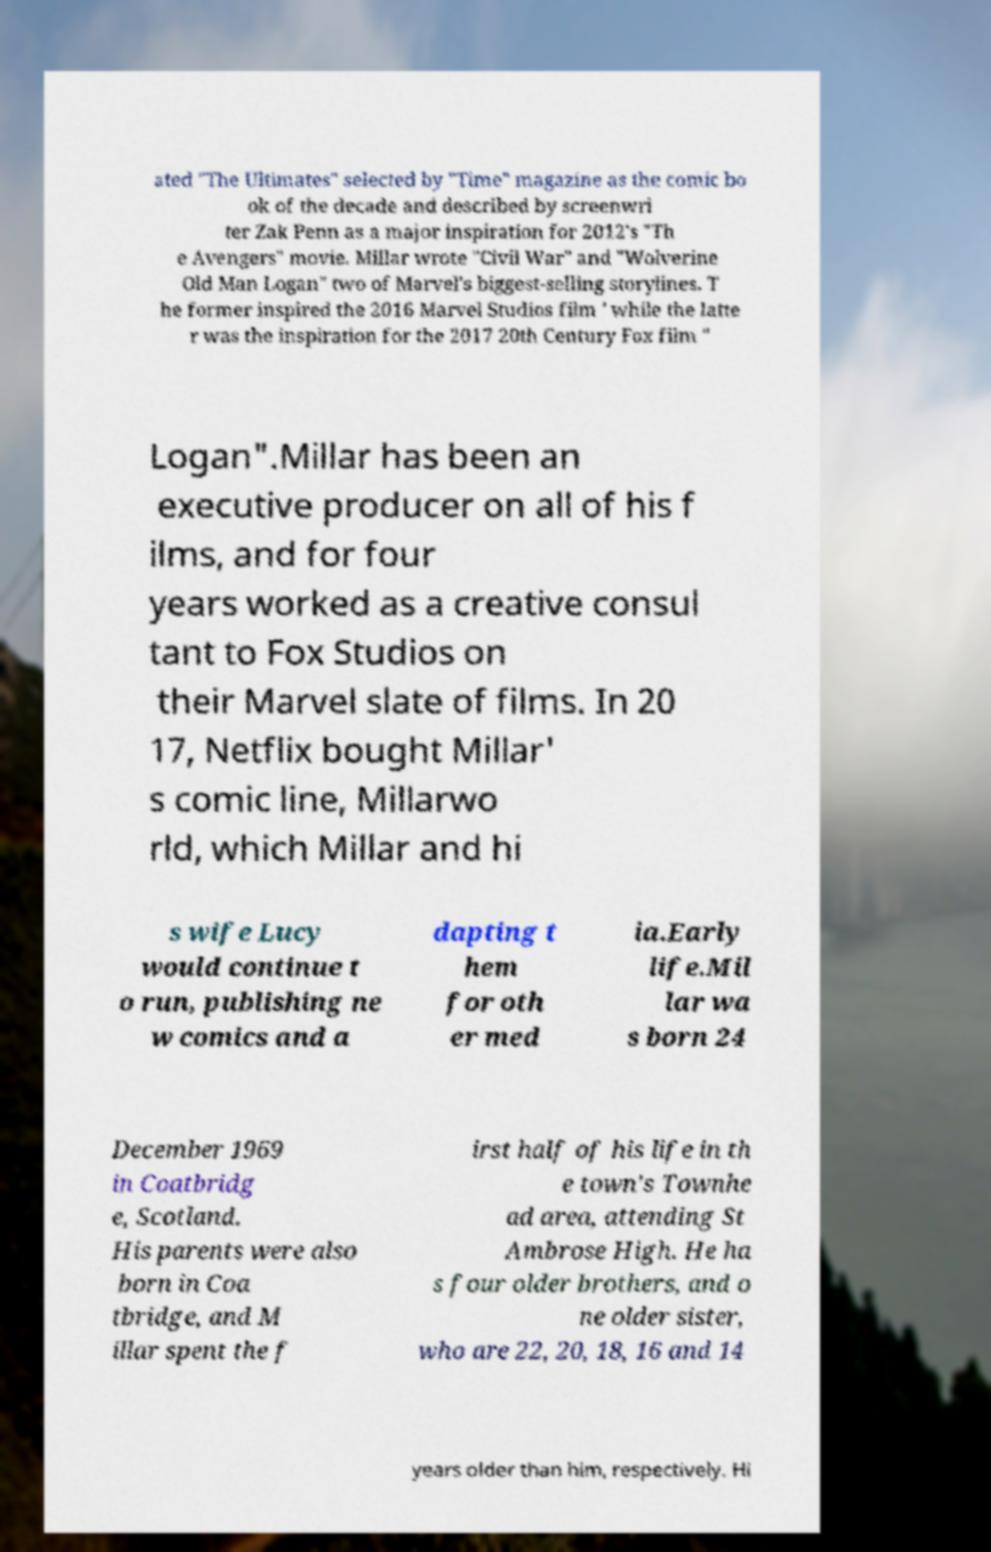Could you extract and type out the text from this image? ated "The Ultimates" selected by "Time" magazine as the comic bo ok of the decade and described by screenwri ter Zak Penn as a major inspiration for 2012's "Th e Avengers" movie. Millar wrote "Civil War" and "Wolverine Old Man Logan" two of Marvel's biggest-selling storylines. T he former inspired the 2016 Marvel Studios film ' while the latte r was the inspiration for the 2017 20th Century Fox film " Logan".Millar has been an executive producer on all of his f ilms, and for four years worked as a creative consul tant to Fox Studios on their Marvel slate of films. In 20 17, Netflix bought Millar' s comic line, Millarwo rld, which Millar and hi s wife Lucy would continue t o run, publishing ne w comics and a dapting t hem for oth er med ia.Early life.Mil lar wa s born 24 December 1969 in Coatbridg e, Scotland. His parents were also born in Coa tbridge, and M illar spent the f irst half of his life in th e town's Townhe ad area, attending St Ambrose High. He ha s four older brothers, and o ne older sister, who are 22, 20, 18, 16 and 14 years older than him, respectively. Hi 